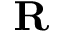Convert formula to latex. <formula><loc_0><loc_0><loc_500><loc_500>R</formula> 